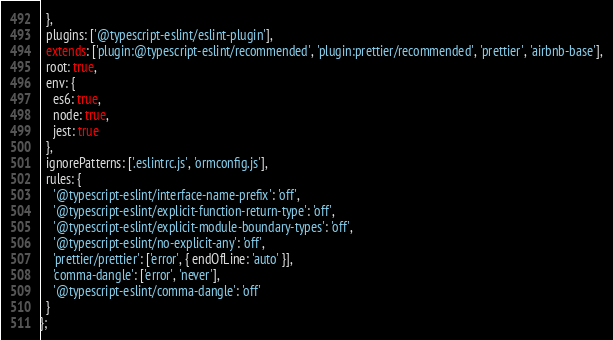<code> <loc_0><loc_0><loc_500><loc_500><_JavaScript_>  },
  plugins: ['@typescript-eslint/eslint-plugin'],
  extends: ['plugin:@typescript-eslint/recommended', 'plugin:prettier/recommended', 'prettier', 'airbnb-base'],
  root: true,
  env: {
    es6: true,
    node: true,
    jest: true
  },
  ignorePatterns: ['.eslintrc.js', 'ormconfig.js'],
  rules: {
    '@typescript-eslint/interface-name-prefix': 'off',
    '@typescript-eslint/explicit-function-return-type': 'off',
    '@typescript-eslint/explicit-module-boundary-types': 'off',
    '@typescript-eslint/no-explicit-any': 'off',
    'prettier/prettier': ['error', { endOfLine: 'auto' }],
    'comma-dangle': ['error', 'never'],
    '@typescript-eslint/comma-dangle': 'off'
  }
};
</code> 